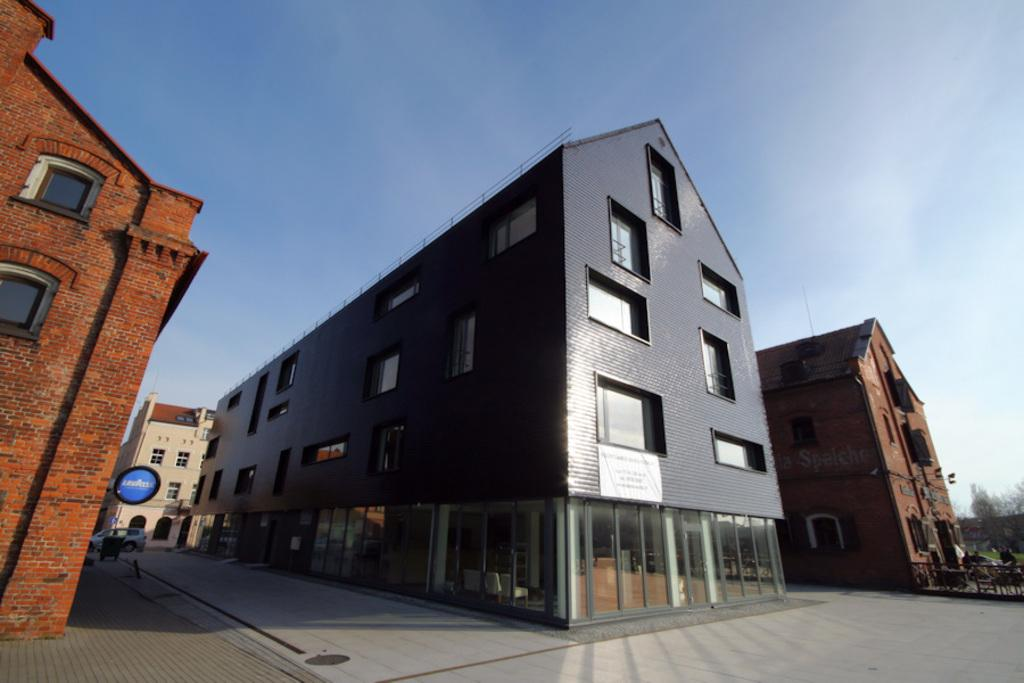What type of structures can be seen in the image? There are buildings with windows in the image. What is located near the buildings? There is a signboard in the image. What mode of transportation is present in the image? There is a car in the image. What type of barrier is visible in the image? There is a fence in the image. What type of vegetation is present in the image? There are trees in the image. What is the condition of the sky in the image? The sky is visible in the image and appears cloudy. How much was the payment for the crime committed in the image? There is no crime or payment mentioned in the image; it only features buildings, a signboard, a car, a fence, trees, and a cloudy sky. 